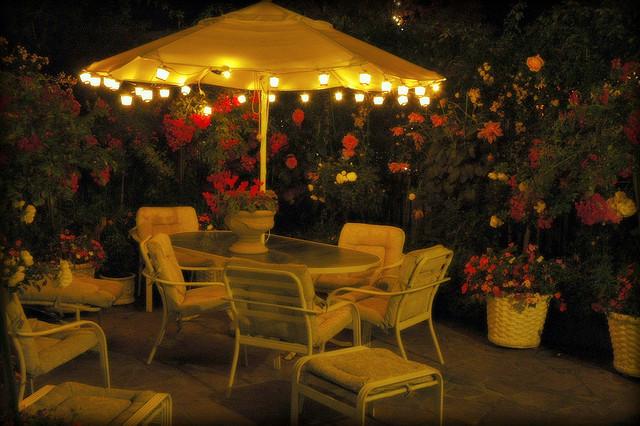Are the lights on?
Concise answer only. Yes. What surrounds the patio?
Write a very short answer. Flowers. What color is the canopy?
Quick response, please. White. What color is the patio furniture?
Write a very short answer. White. 